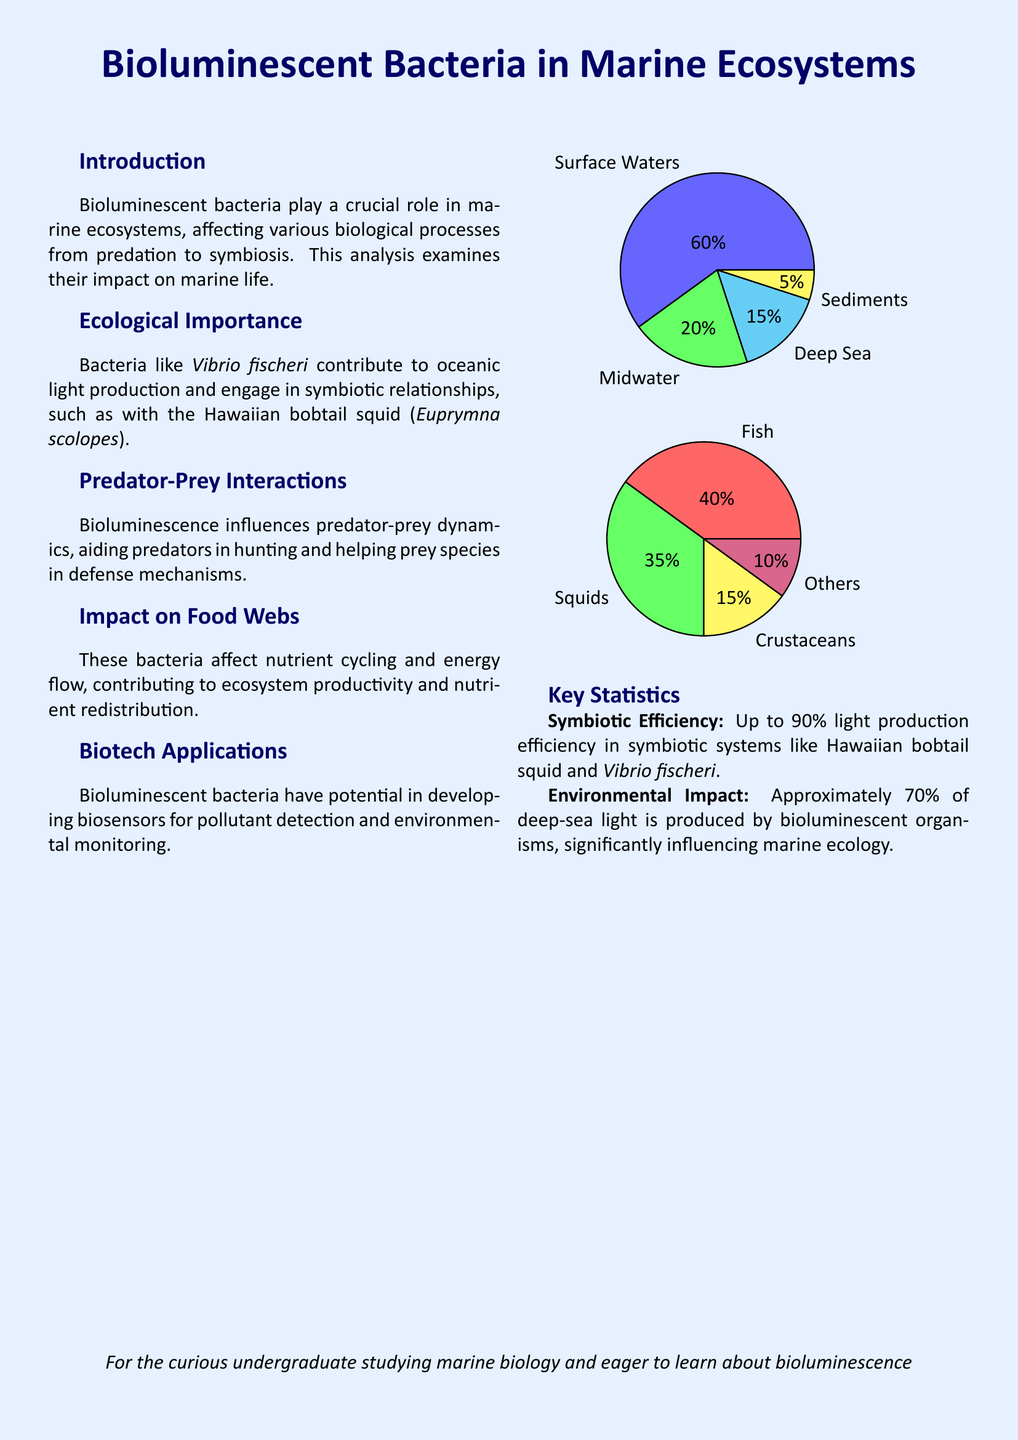What is the main focus of the analysis? The main focus of the analysis is bioluminescent bacteria and their role in marine ecosystems.
Answer: bioluminescent bacteria and their role in marine ecosystems What is the symbiotic relationship mentioned in the document? The document mentions the symbiotic relationship between the Hawaiian bobtail squid and Vibrio fischeri.
Answer: Hawaiian bobtail squid and Vibrio fischeri What percentage of deep-sea light is produced by bioluminescent organisms? The document states that approximately 70% of deep-sea light is produced by bioluminescent organisms.
Answer: 70% What role do bioluminescent bacteria play in predator-prey dynamics? Bioluminescence aids predators in hunting and helps prey species in defense mechanisms.
Answer: aids predators in hunting and helps prey in defense What is one potential biotechnological application of bioluminescent bacteria? The document suggests that bioluminescent bacteria could be developed for biosensors in pollutant detection.
Answer: biosensors for pollutant detection What is the efficiency of light production in symbiotic systems? The document cites that the light production efficiency can be up to 90% in symbiotic systems like the Hawaiian bobtail squid.
Answer: up to 90% Which marine environments are represented in the first pie chart? The first pie chart represents surface waters, midwater, deep sea, and sediments.
Answer: surface waters, midwater, deep sea, sediments What type of marine animals is highlighted in the second pie chart? The second pie chart highlights fish, squids, crustaceans, and others as marine animals.
Answer: fish, squids, crustaceans, others 